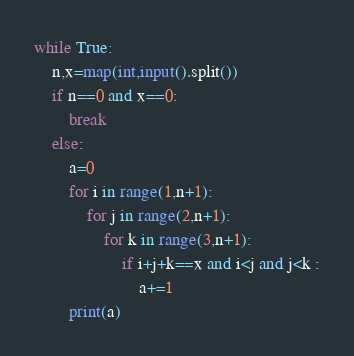Convert code to text. <code><loc_0><loc_0><loc_500><loc_500><_Python_>while True:
    n,x=map(int,input().split())
    if n==0 and x==0:
        break
    else:
        a=0
        for i in range(1,n+1):
            for j in range(2,n+1):
                for k in range(3,n+1):
                    if i+j+k==x and i<j and j<k :
                        a+=1
        print(a)
</code> 